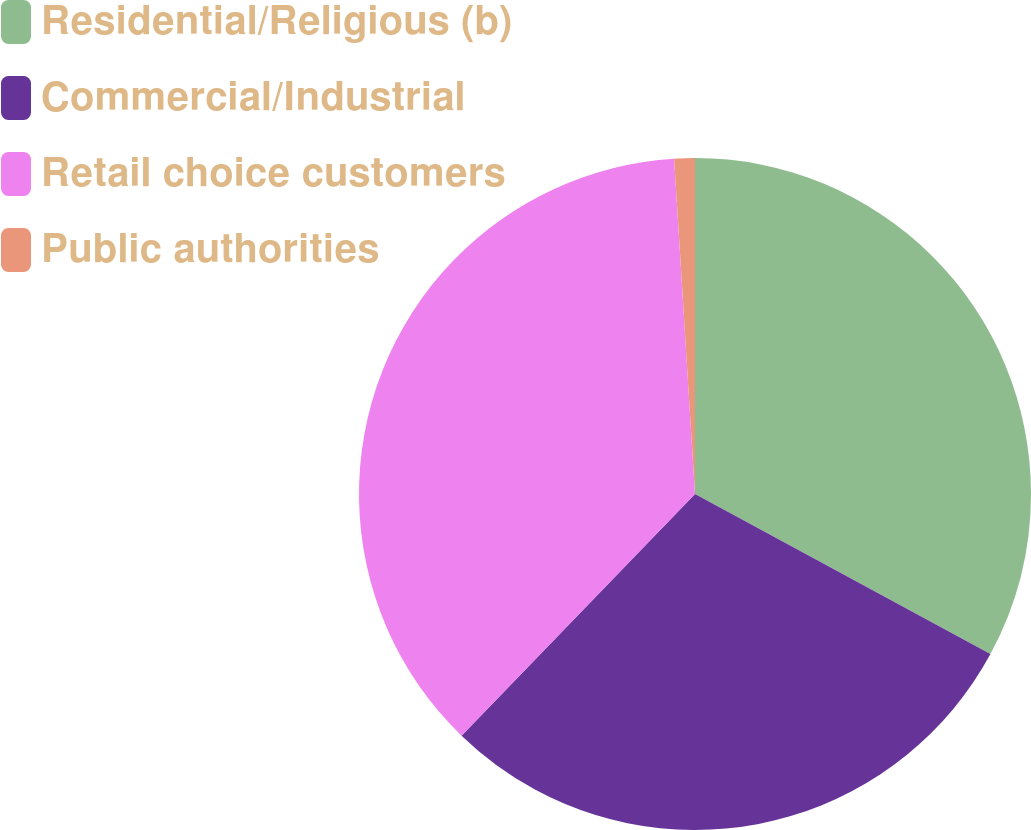Convert chart to OTSL. <chart><loc_0><loc_0><loc_500><loc_500><pie_chart><fcel>Residential/Religious (b)<fcel>Commercial/Industrial<fcel>Retail choice customers<fcel>Public authorities<nl><fcel>32.9%<fcel>29.32%<fcel>36.78%<fcel>0.99%<nl></chart> 